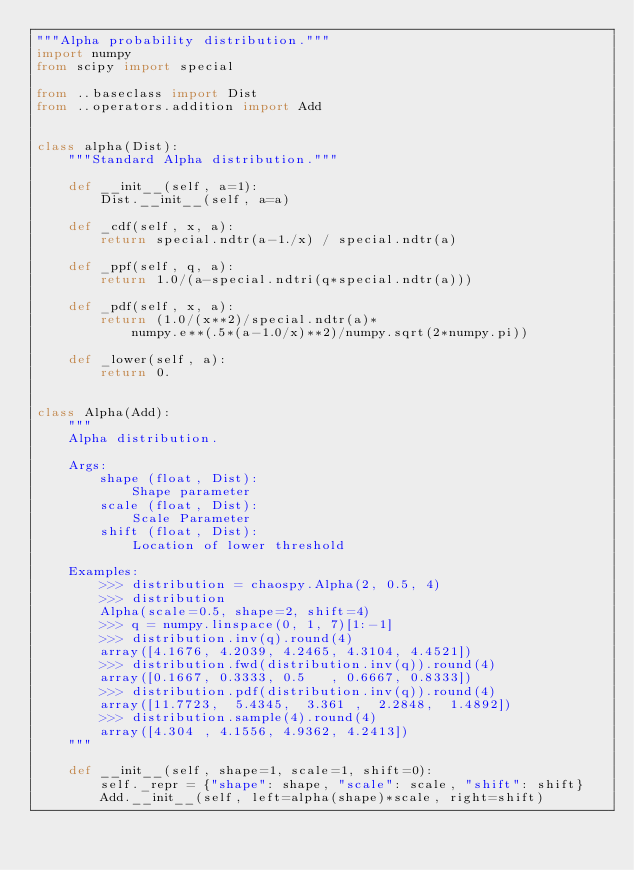<code> <loc_0><loc_0><loc_500><loc_500><_Python_>"""Alpha probability distribution."""
import numpy
from scipy import special

from ..baseclass import Dist
from ..operators.addition import Add


class alpha(Dist):
    """Standard Alpha distribution."""

    def __init__(self, a=1):
        Dist.__init__(self, a=a)

    def _cdf(self, x, a):
        return special.ndtr(a-1./x) / special.ndtr(a)

    def _ppf(self, q, a):
        return 1.0/(a-special.ndtri(q*special.ndtr(a)))

    def _pdf(self, x, a):
        return (1.0/(x**2)/special.ndtr(a)*
            numpy.e**(.5*(a-1.0/x)**2)/numpy.sqrt(2*numpy.pi))

    def _lower(self, a):
        return 0.


class Alpha(Add):
    """
    Alpha distribution.

    Args:
        shape (float, Dist):
            Shape parameter
        scale (float, Dist):
            Scale Parameter
        shift (float, Dist):
            Location of lower threshold

    Examples:
        >>> distribution = chaospy.Alpha(2, 0.5, 4)
        >>> distribution
        Alpha(scale=0.5, shape=2, shift=4)
        >>> q = numpy.linspace(0, 1, 7)[1:-1]
        >>> distribution.inv(q).round(4)
        array([4.1676, 4.2039, 4.2465, 4.3104, 4.4521])
        >>> distribution.fwd(distribution.inv(q)).round(4)
        array([0.1667, 0.3333, 0.5   , 0.6667, 0.8333])
        >>> distribution.pdf(distribution.inv(q)).round(4)
        array([11.7723,  5.4345,  3.361 ,  2.2848,  1.4892])
        >>> distribution.sample(4).round(4)
        array([4.304 , 4.1556, 4.9362, 4.2413])
    """

    def __init__(self, shape=1, scale=1, shift=0):
        self._repr = {"shape": shape, "scale": scale, "shift": shift}
        Add.__init__(self, left=alpha(shape)*scale, right=shift)
</code> 